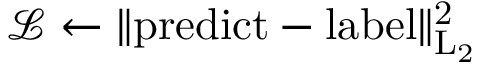Convert formula to latex. <formula><loc_0><loc_0><loc_500><loc_500>\mathcal { L } \gets \| { p r e d i c t } - \mathrm { { l a b e l } \| _ { L _ { 2 } } ^ { 2 } }</formula> 